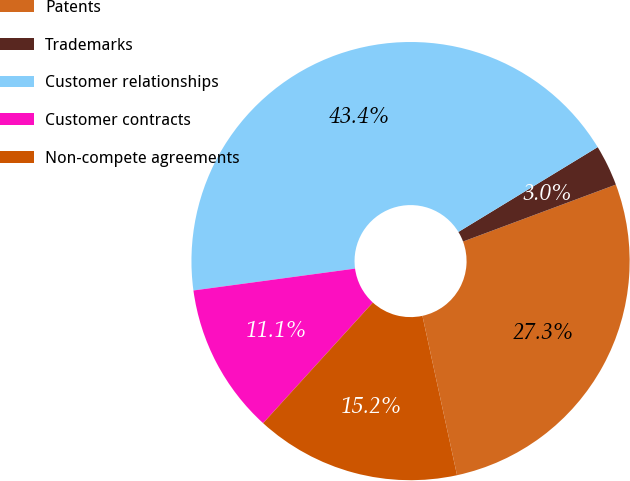<chart> <loc_0><loc_0><loc_500><loc_500><pie_chart><fcel>Patents<fcel>Trademarks<fcel>Customer relationships<fcel>Customer contracts<fcel>Non-compete agreements<nl><fcel>27.27%<fcel>3.03%<fcel>43.43%<fcel>11.11%<fcel>15.15%<nl></chart> 